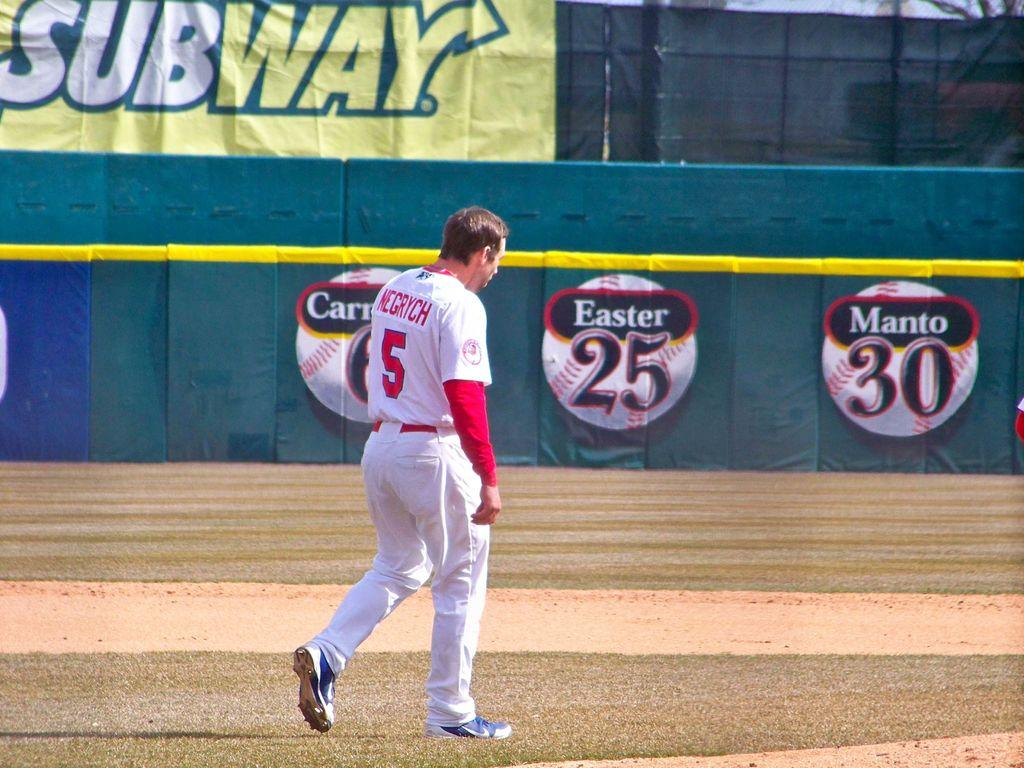<image>
Provide a brief description of the given image. The food franchise Subway is advertised at this park. 